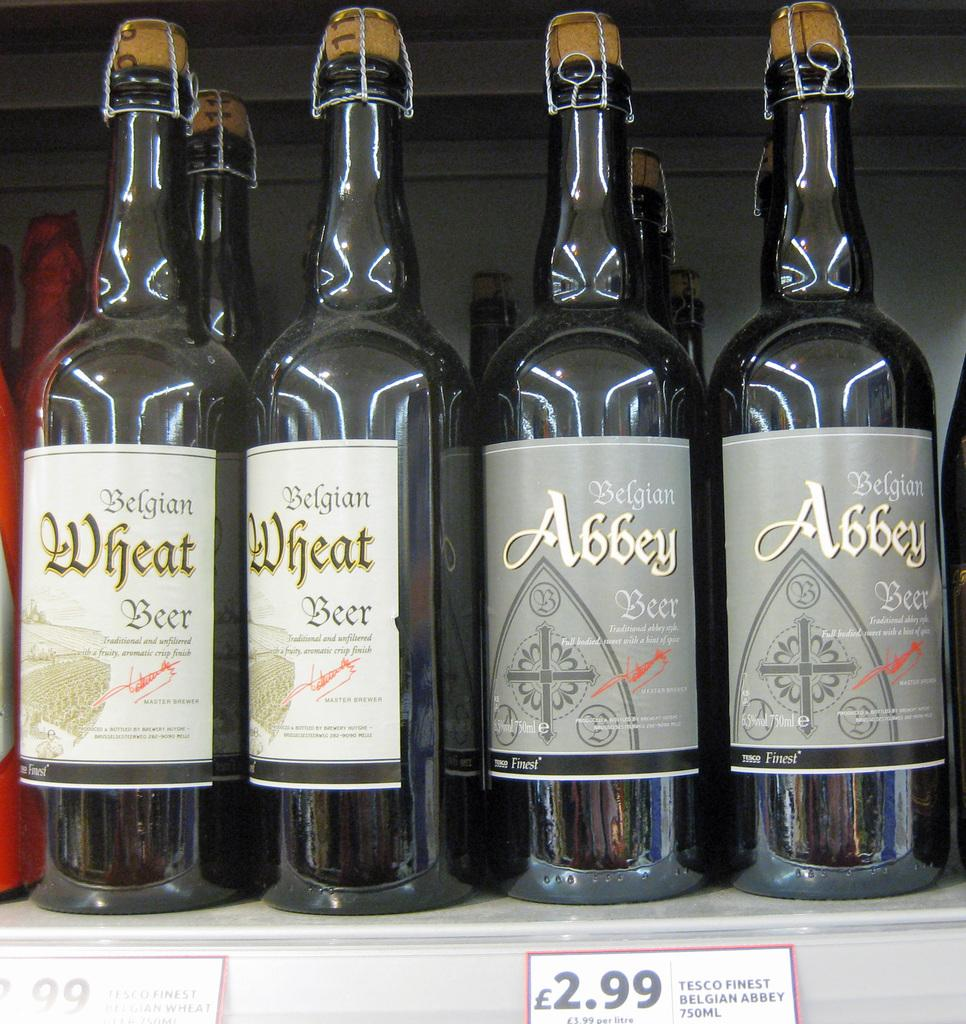Provide a one-sentence caption for the provided image. Four bottles of Belgian beer sitting on a shelf. 